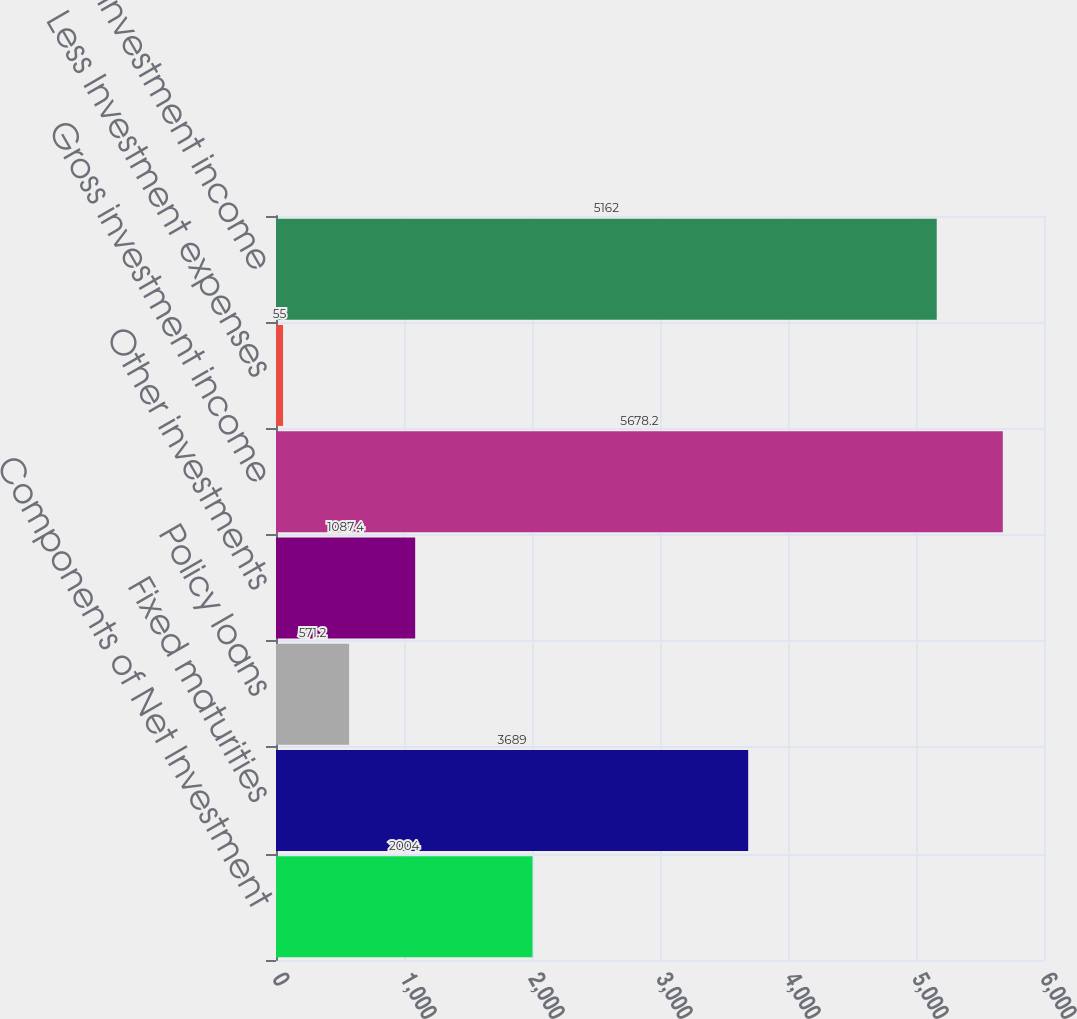Convert chart. <chart><loc_0><loc_0><loc_500><loc_500><bar_chart><fcel>Components of Net Investment<fcel>Fixed maturities<fcel>Policy loans<fcel>Other investments<fcel>Gross investment income<fcel>Less Investment expenses<fcel>Net investment income<nl><fcel>2004<fcel>3689<fcel>571.2<fcel>1087.4<fcel>5678.2<fcel>55<fcel>5162<nl></chart> 